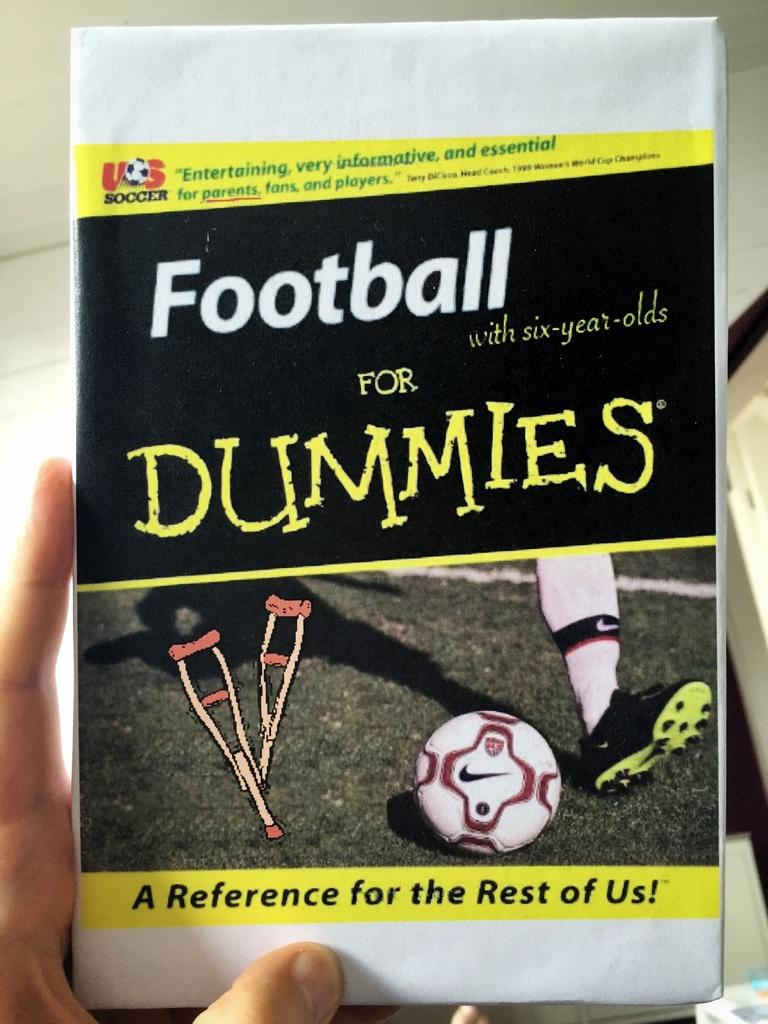<image>
Relay a brief, clear account of the picture shown. A hand holding the book Football for Dummies. 